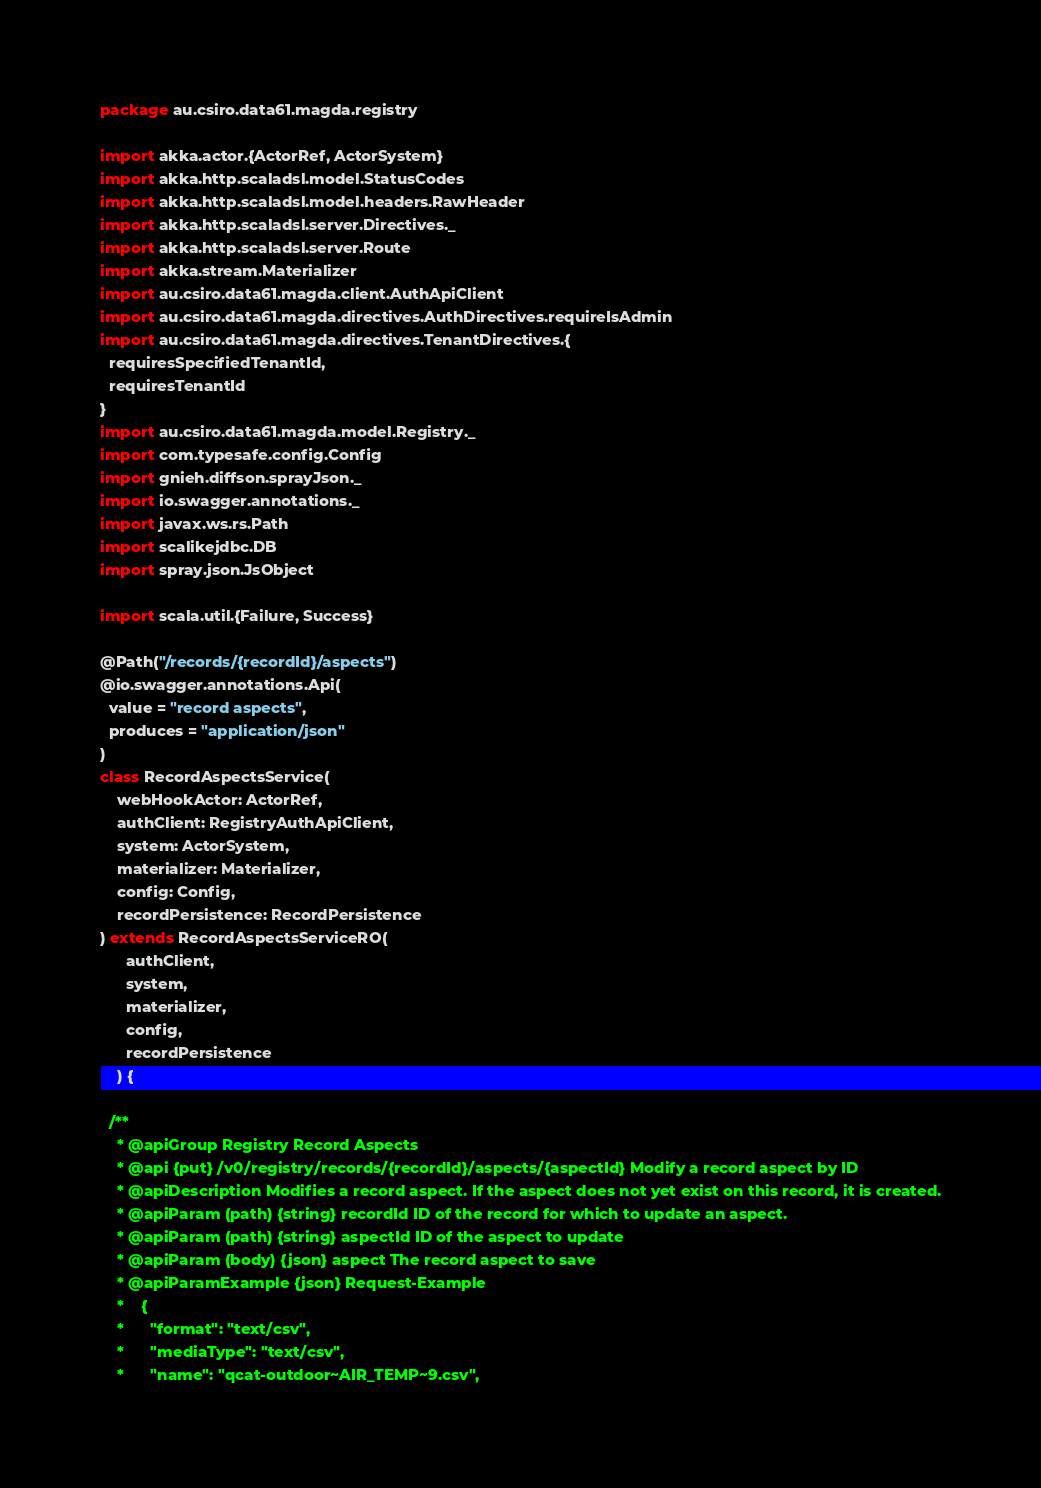Convert code to text. <code><loc_0><loc_0><loc_500><loc_500><_Scala_>package au.csiro.data61.magda.registry

import akka.actor.{ActorRef, ActorSystem}
import akka.http.scaladsl.model.StatusCodes
import akka.http.scaladsl.model.headers.RawHeader
import akka.http.scaladsl.server.Directives._
import akka.http.scaladsl.server.Route
import akka.stream.Materializer
import au.csiro.data61.magda.client.AuthApiClient
import au.csiro.data61.magda.directives.AuthDirectives.requireIsAdmin
import au.csiro.data61.magda.directives.TenantDirectives.{
  requiresSpecifiedTenantId,
  requiresTenantId
}
import au.csiro.data61.magda.model.Registry._
import com.typesafe.config.Config
import gnieh.diffson.sprayJson._
import io.swagger.annotations._
import javax.ws.rs.Path
import scalikejdbc.DB
import spray.json.JsObject

import scala.util.{Failure, Success}

@Path("/records/{recordId}/aspects")
@io.swagger.annotations.Api(
  value = "record aspects",
  produces = "application/json"
)
class RecordAspectsService(
    webHookActor: ActorRef,
    authClient: RegistryAuthApiClient,
    system: ActorSystem,
    materializer: Materializer,
    config: Config,
    recordPersistence: RecordPersistence
) extends RecordAspectsServiceRO(
      authClient,
      system,
      materializer,
      config,
      recordPersistence
    ) {

  /**
    * @apiGroup Registry Record Aspects
    * @api {put} /v0/registry/records/{recordId}/aspects/{aspectId} Modify a record aspect by ID
    * @apiDescription Modifies a record aspect. If the aspect does not yet exist on this record, it is created.
    * @apiParam (path) {string} recordId ID of the record for which to update an aspect.
    * @apiParam (path) {string} aspectId ID of the aspect to update
    * @apiParam (body) {json} aspect The record aspect to save
    * @apiParamExample {json} Request-Example
    *    {
    *      "format": "text/csv",
    *      "mediaType": "text/csv",
    *      "name": "qcat-outdoor~AIR_TEMP~9.csv",</code> 